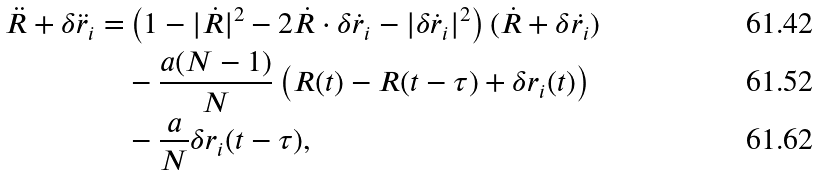<formula> <loc_0><loc_0><loc_500><loc_500>\ddot { R } + \delta \ddot { r } _ { i } = & \left ( 1 - | \dot { R } | ^ { 2 } - 2 \dot { R } \cdot \delta \dot { r } _ { i } - | \delta \dot { r } _ { i } | ^ { 2 } \right ) ( \dot { R } + \delta \dot { r _ { i } } ) \\ & - \frac { a ( N - 1 ) } { N } \left ( R ( t ) - R ( t - \tau ) + \delta r _ { i } ( t ) \right ) \\ & - \frac { a } { N } \delta r _ { i } ( t - \tau ) ,</formula> 